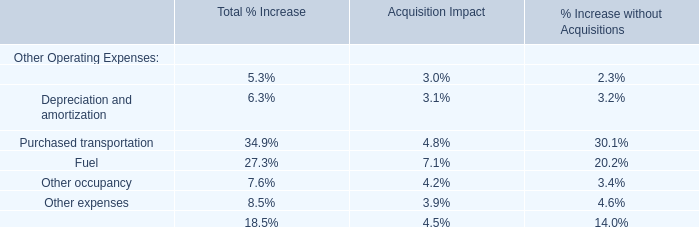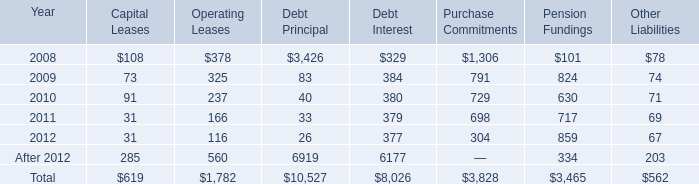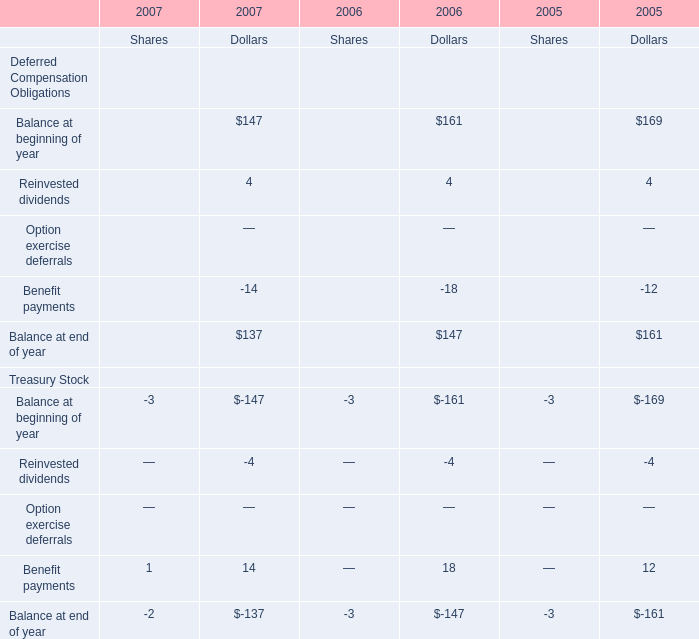What is the ratio of Reinvested dividends for dollars to the total in 2006? 
Computations: (4 / 147)
Answer: 0.02721. 